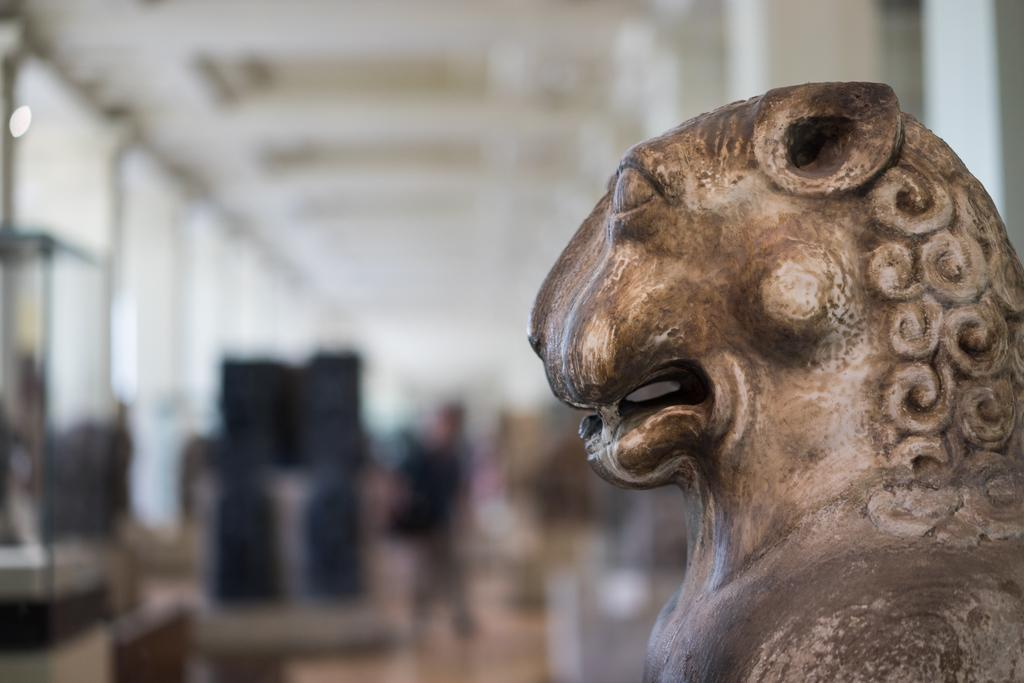What is the main subject in the image? There is a statue in the image. Can you describe the background of the image? The background of the image is blurry. What type of yarn is being used to create the statue in the image? There is no mention of yarn being used to create the statue in the image. What substance is the statue made of in the image? The facts provided do not specify the substance the statue is made of. 